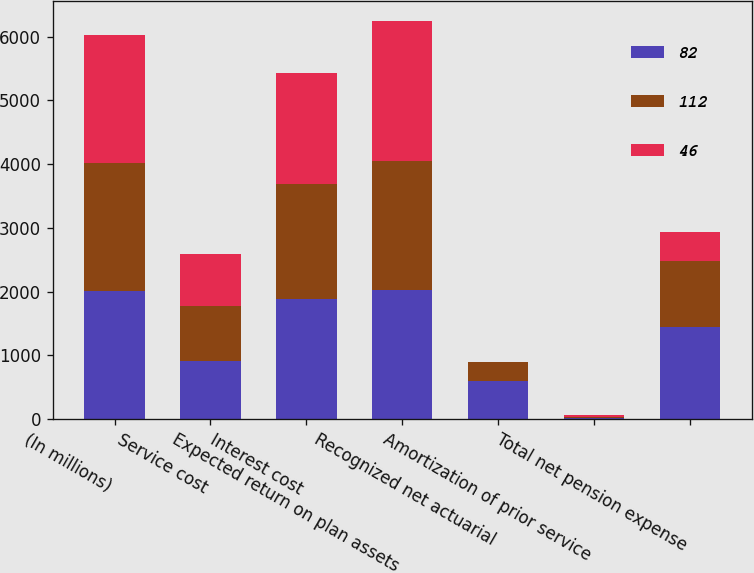Convert chart to OTSL. <chart><loc_0><loc_0><loc_500><loc_500><stacked_bar_chart><ecel><fcel>(In millions)<fcel>Service cost<fcel>Interest cost<fcel>Expected return on plan assets<fcel>Recognized net actuarial<fcel>Amortization of prior service<fcel>Total net pension expense<nl><fcel>82<fcel>2010<fcel>903<fcel>1876<fcel>2027<fcel>595<fcel>16<fcel>1442<nl><fcel>112<fcel>2009<fcel>870<fcel>1812<fcel>2028<fcel>302<fcel>23<fcel>1036<nl><fcel>46<fcel>2008<fcel>823<fcel>1741<fcel>2184<fcel>2<fcel>25<fcel>462<nl></chart> 